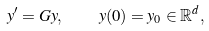<formula> <loc_0><loc_0><loc_500><loc_500>y ^ { \prime } = G y , \quad y ( 0 ) = y _ { 0 } \in \mathbb { R } ^ { d } ,</formula> 